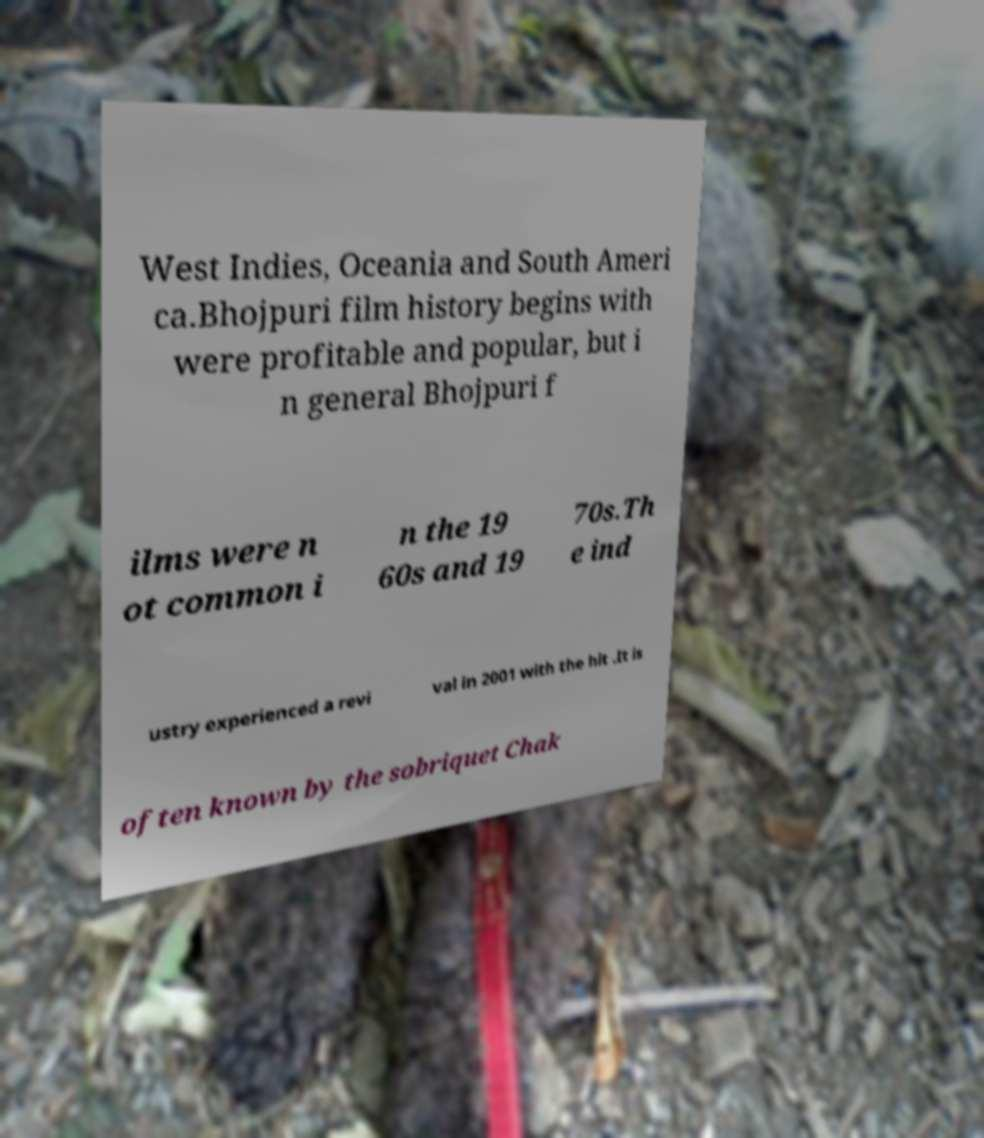There's text embedded in this image that I need extracted. Can you transcribe it verbatim? West Indies, Oceania and South Ameri ca.Bhojpuri film history begins with were profitable and popular, but i n general Bhojpuri f ilms were n ot common i n the 19 60s and 19 70s.Th e ind ustry experienced a revi val in 2001 with the hit .It is often known by the sobriquet Chak 